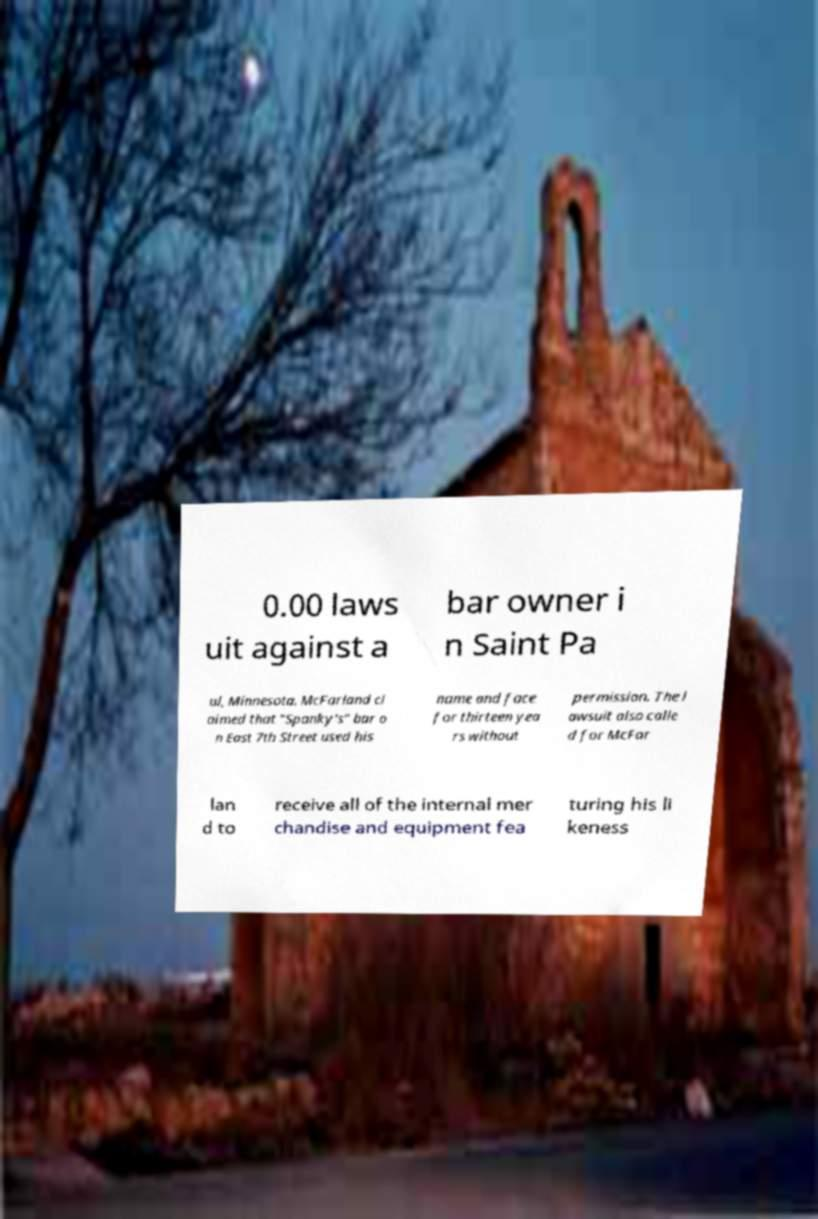For documentation purposes, I need the text within this image transcribed. Could you provide that? 0.00 laws uit against a bar owner i n Saint Pa ul, Minnesota. McFarland cl aimed that "Spanky's" bar o n East 7th Street used his name and face for thirteen yea rs without permission. The l awsuit also calle d for McFar lan d to receive all of the internal mer chandise and equipment fea turing his li keness 